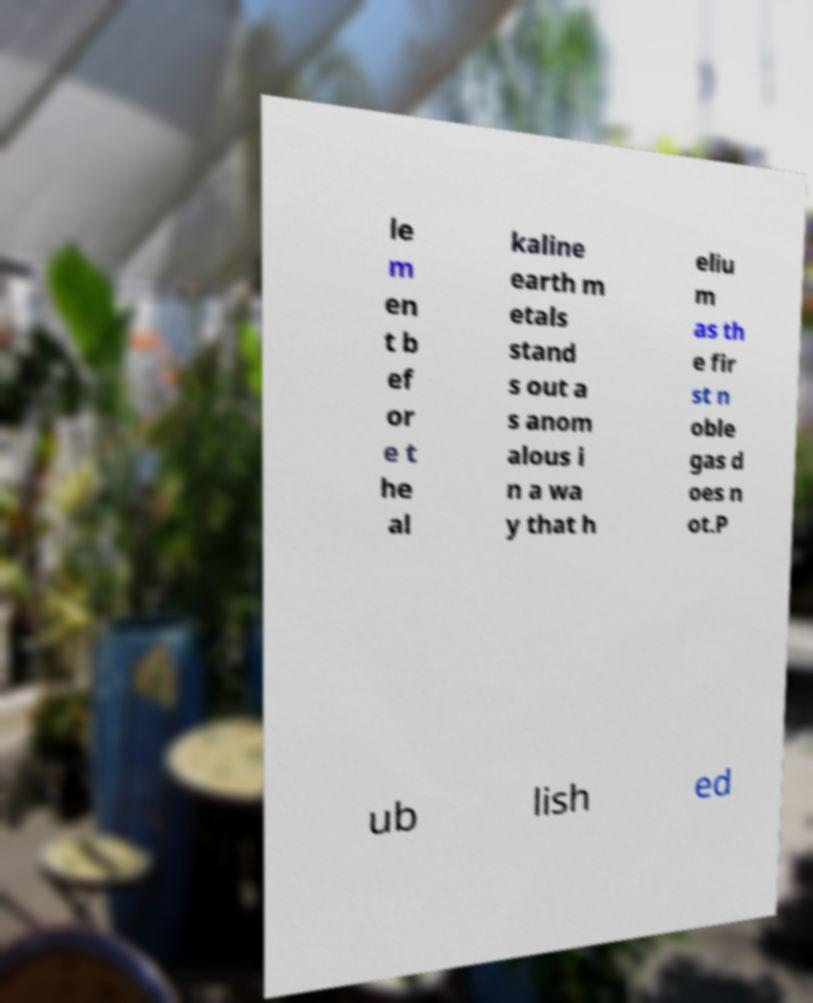What messages or text are displayed in this image? I need them in a readable, typed format. le m en t b ef or e t he al kaline earth m etals stand s out a s anom alous i n a wa y that h eliu m as th e fir st n oble gas d oes n ot.P ub lish ed 